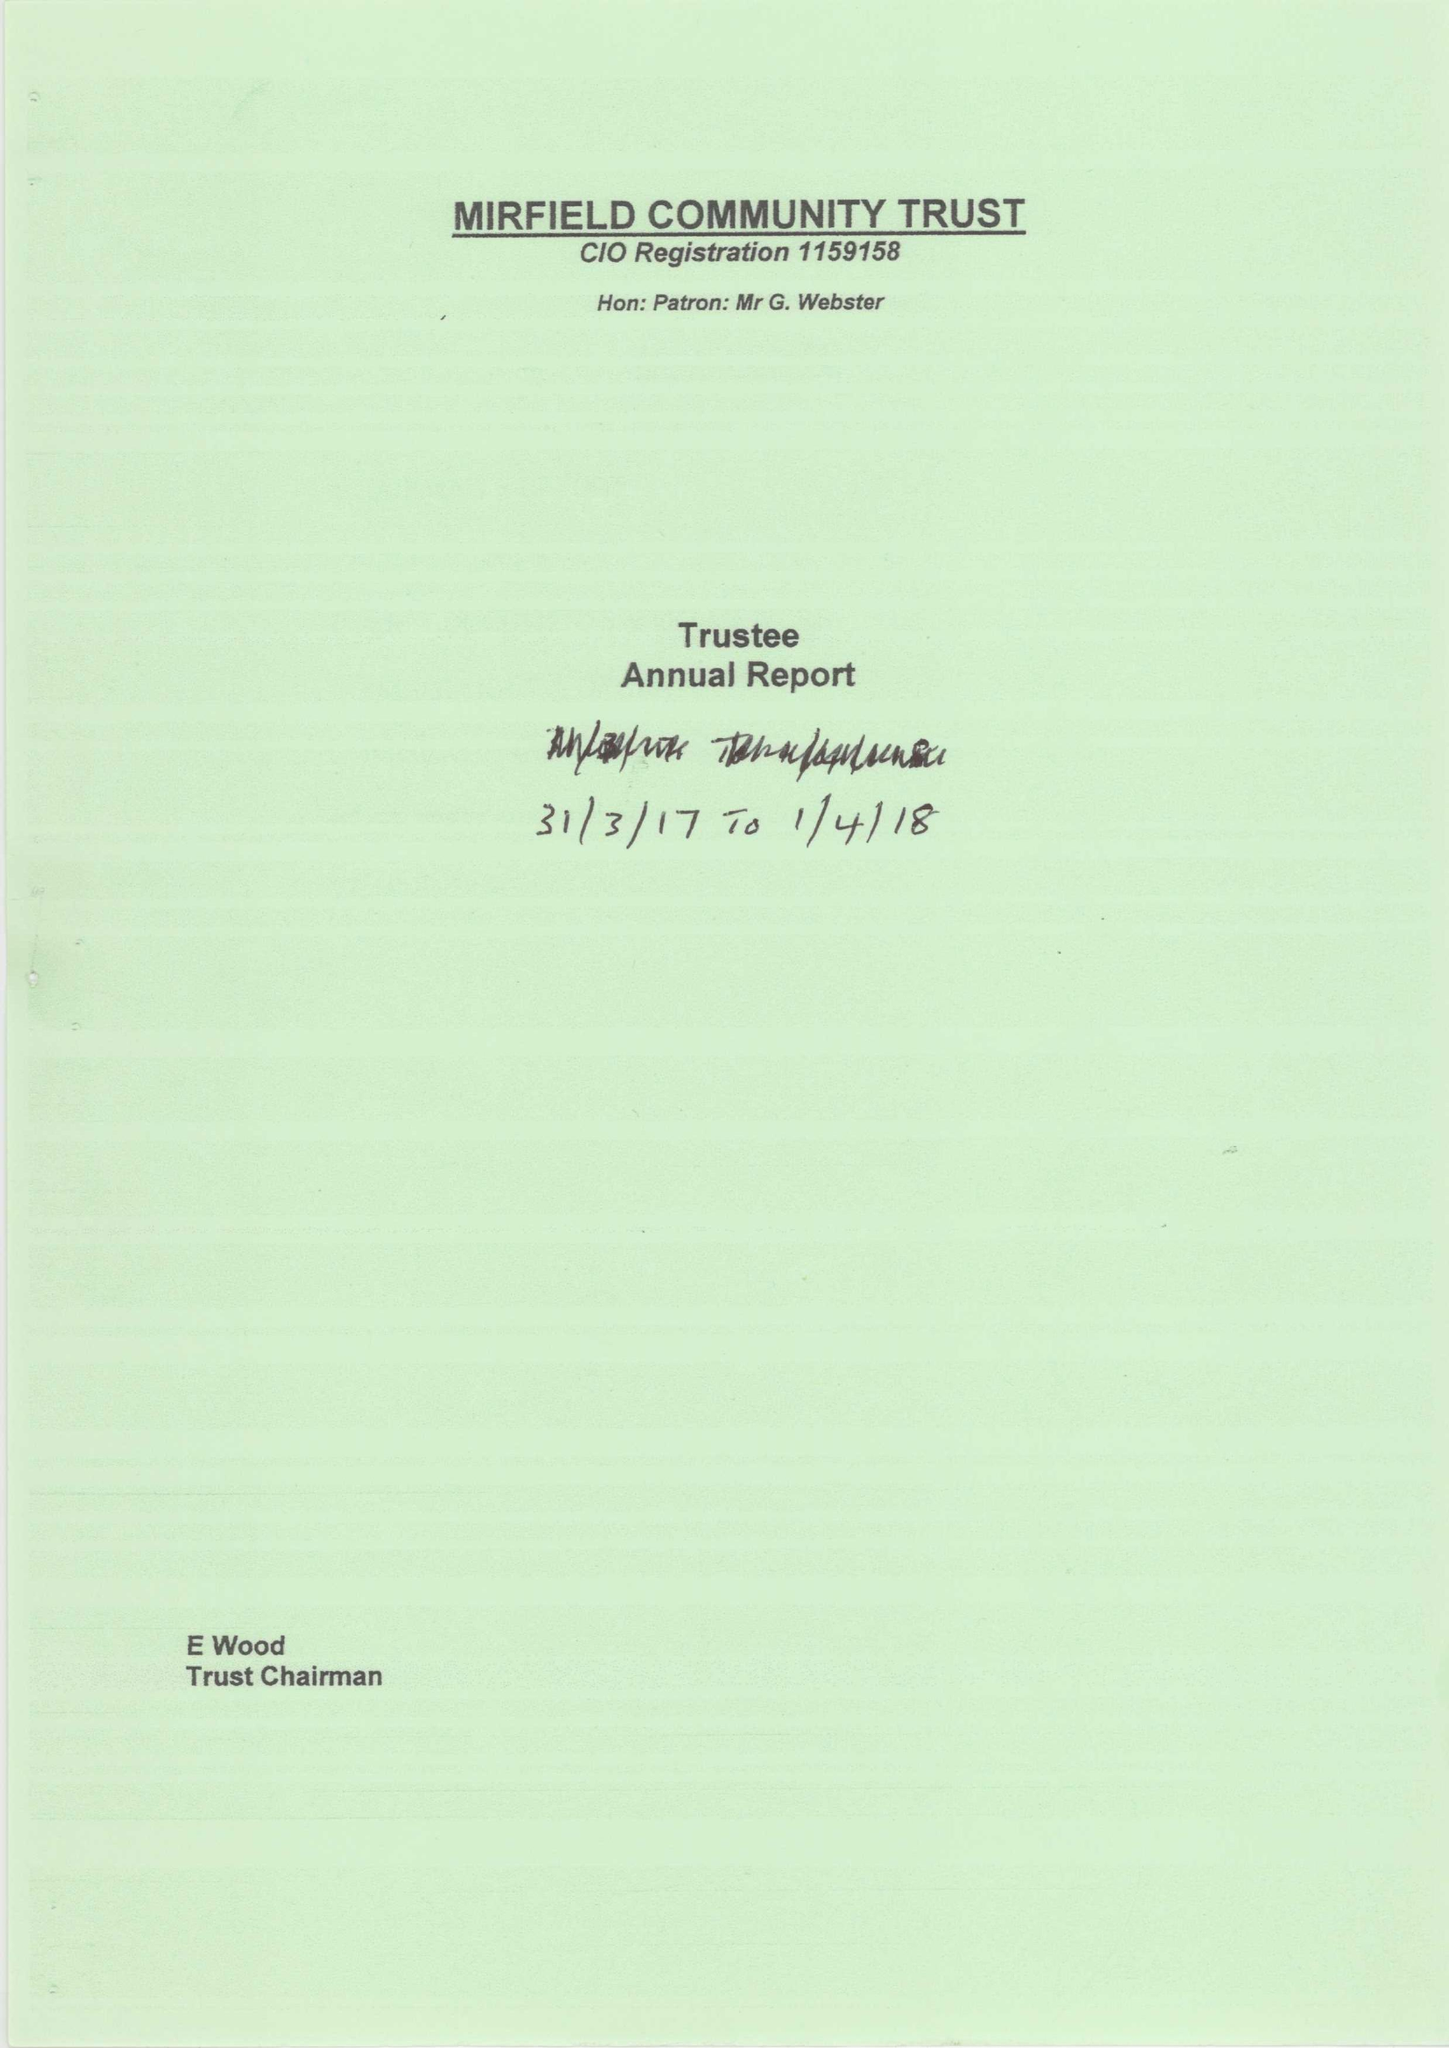What is the value for the income_annually_in_british_pounds?
Answer the question using a single word or phrase. 9457.00 